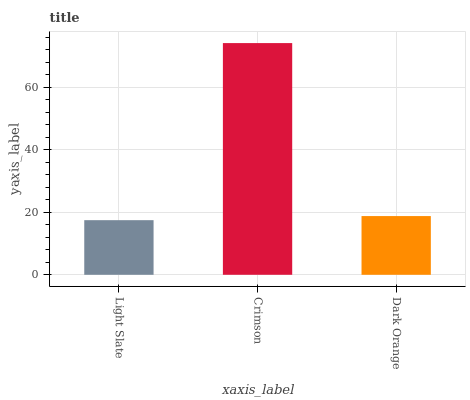Is Light Slate the minimum?
Answer yes or no. Yes. Is Crimson the maximum?
Answer yes or no. Yes. Is Dark Orange the minimum?
Answer yes or no. No. Is Dark Orange the maximum?
Answer yes or no. No. Is Crimson greater than Dark Orange?
Answer yes or no. Yes. Is Dark Orange less than Crimson?
Answer yes or no. Yes. Is Dark Orange greater than Crimson?
Answer yes or no. No. Is Crimson less than Dark Orange?
Answer yes or no. No. Is Dark Orange the high median?
Answer yes or no. Yes. Is Dark Orange the low median?
Answer yes or no. Yes. Is Light Slate the high median?
Answer yes or no. No. Is Crimson the low median?
Answer yes or no. No. 